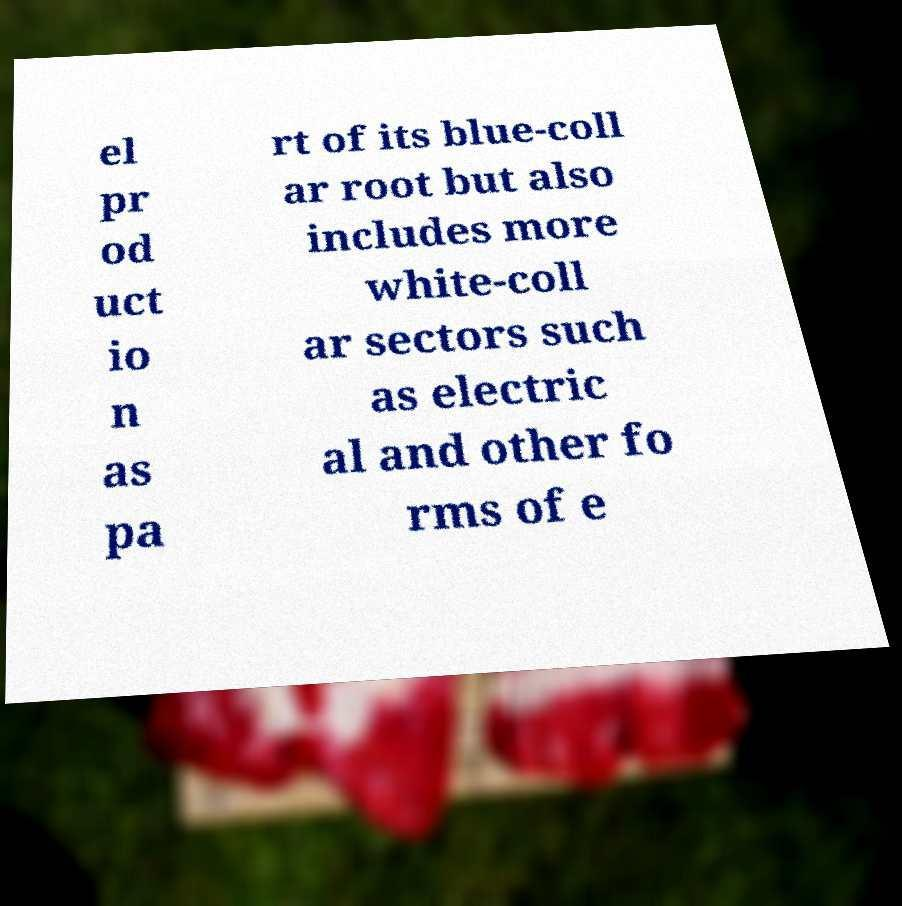Can you accurately transcribe the text from the provided image for me? el pr od uct io n as pa rt of its blue-coll ar root but also includes more white-coll ar sectors such as electric al and other fo rms of e 